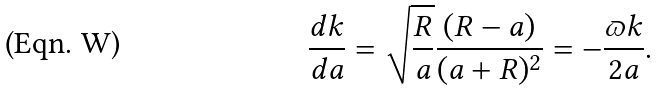Convert formula to latex. <formula><loc_0><loc_0><loc_500><loc_500>\frac { d k } { d a } = \sqrt { \frac { R } { a } } \frac { ( R - a ) } { ( a + R ) ^ { 2 } } = - \frac { \varpi k } { 2 a } .</formula> 